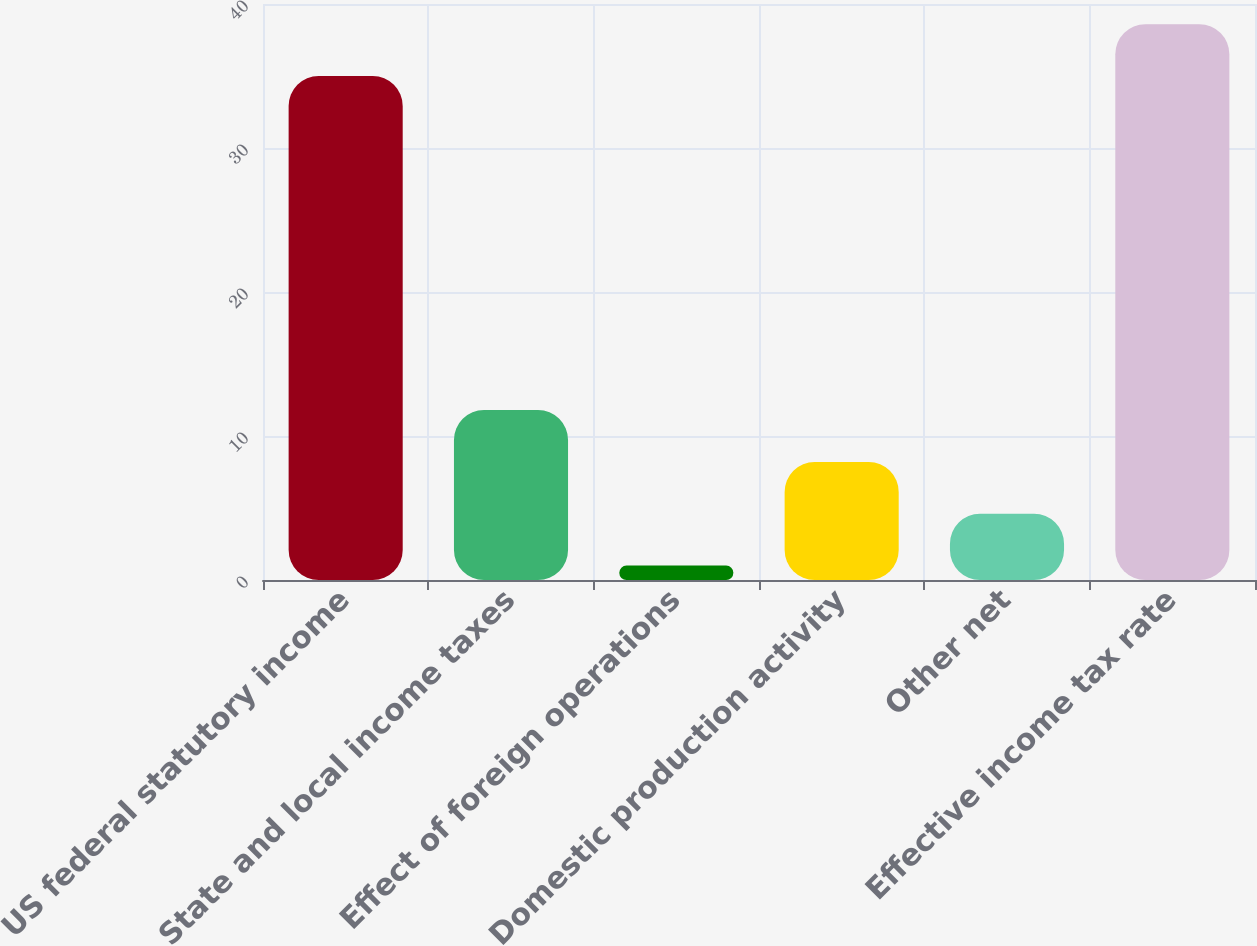<chart> <loc_0><loc_0><loc_500><loc_500><bar_chart><fcel>US federal statutory income<fcel>State and local income taxes<fcel>Effect of foreign operations<fcel>Domestic production activity<fcel>Other net<fcel>Effective income tax rate<nl><fcel>35<fcel>11.8<fcel>1<fcel>8.2<fcel>4.6<fcel>38.6<nl></chart> 